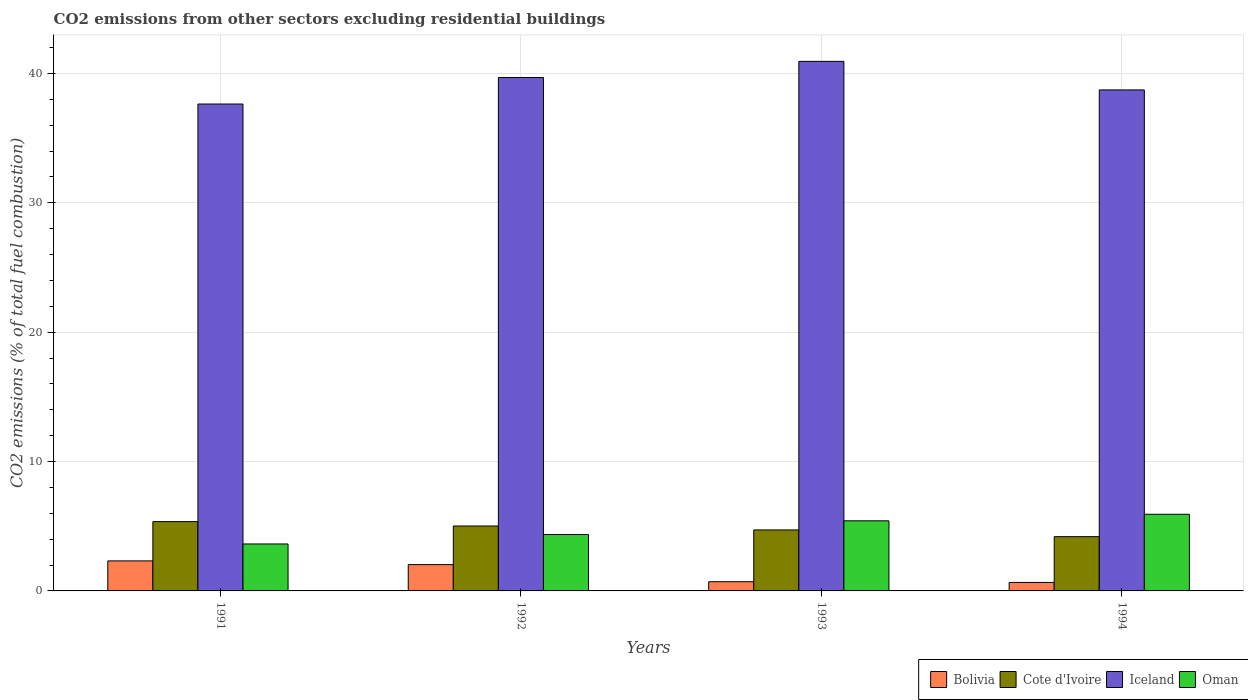How many groups of bars are there?
Offer a terse response. 4. How many bars are there on the 3rd tick from the left?
Offer a terse response. 4. What is the total CO2 emitted in Cote d'Ivoire in 1994?
Provide a short and direct response. 4.19. Across all years, what is the maximum total CO2 emitted in Cote d'Ivoire?
Your response must be concise. 5.36. Across all years, what is the minimum total CO2 emitted in Oman?
Keep it short and to the point. 3.63. In which year was the total CO2 emitted in Iceland maximum?
Your response must be concise. 1993. What is the total total CO2 emitted in Cote d'Ivoire in the graph?
Provide a short and direct response. 19.28. What is the difference between the total CO2 emitted in Bolivia in 1991 and that in 1992?
Offer a terse response. 0.29. What is the difference between the total CO2 emitted in Bolivia in 1992 and the total CO2 emitted in Oman in 1991?
Your response must be concise. -1.6. What is the average total CO2 emitted in Cote d'Ivoire per year?
Offer a terse response. 4.82. In the year 1991, what is the difference between the total CO2 emitted in Bolivia and total CO2 emitted in Oman?
Give a very brief answer. -1.31. In how many years, is the total CO2 emitted in Bolivia greater than 30?
Offer a terse response. 0. What is the ratio of the total CO2 emitted in Oman in 1991 to that in 1993?
Offer a very short reply. 0.67. Is the difference between the total CO2 emitted in Bolivia in 1992 and 1993 greater than the difference between the total CO2 emitted in Oman in 1992 and 1993?
Your answer should be compact. Yes. What is the difference between the highest and the second highest total CO2 emitted in Iceland?
Your answer should be compact. 1.25. What is the difference between the highest and the lowest total CO2 emitted in Iceland?
Offer a very short reply. 3.3. Is the sum of the total CO2 emitted in Oman in 1992 and 1994 greater than the maximum total CO2 emitted in Bolivia across all years?
Your response must be concise. Yes. Is it the case that in every year, the sum of the total CO2 emitted in Iceland and total CO2 emitted in Oman is greater than the sum of total CO2 emitted in Bolivia and total CO2 emitted in Cote d'Ivoire?
Offer a terse response. Yes. What does the 4th bar from the left in 1991 represents?
Ensure brevity in your answer.  Oman. Is it the case that in every year, the sum of the total CO2 emitted in Bolivia and total CO2 emitted in Oman is greater than the total CO2 emitted in Cote d'Ivoire?
Give a very brief answer. Yes. How many bars are there?
Give a very brief answer. 16. What is the difference between two consecutive major ticks on the Y-axis?
Ensure brevity in your answer.  10. Does the graph contain any zero values?
Provide a short and direct response. No. What is the title of the graph?
Offer a terse response. CO2 emissions from other sectors excluding residential buildings. What is the label or title of the X-axis?
Your answer should be compact. Years. What is the label or title of the Y-axis?
Your answer should be compact. CO2 emissions (% of total fuel combustion). What is the CO2 emissions (% of total fuel combustion) in Bolivia in 1991?
Your answer should be compact. 2.32. What is the CO2 emissions (% of total fuel combustion) in Cote d'Ivoire in 1991?
Offer a very short reply. 5.36. What is the CO2 emissions (% of total fuel combustion) in Iceland in 1991?
Offer a terse response. 37.63. What is the CO2 emissions (% of total fuel combustion) of Oman in 1991?
Your answer should be compact. 3.63. What is the CO2 emissions (% of total fuel combustion) of Bolivia in 1992?
Keep it short and to the point. 2.03. What is the CO2 emissions (% of total fuel combustion) in Cote d'Ivoire in 1992?
Ensure brevity in your answer.  5.02. What is the CO2 emissions (% of total fuel combustion) of Iceland in 1992?
Your answer should be very brief. 39.68. What is the CO2 emissions (% of total fuel combustion) of Oman in 1992?
Provide a succinct answer. 4.36. What is the CO2 emissions (% of total fuel combustion) in Bolivia in 1993?
Your answer should be compact. 0.71. What is the CO2 emissions (% of total fuel combustion) in Cote d'Ivoire in 1993?
Make the answer very short. 4.71. What is the CO2 emissions (% of total fuel combustion) of Iceland in 1993?
Provide a succinct answer. 40.93. What is the CO2 emissions (% of total fuel combustion) in Oman in 1993?
Give a very brief answer. 5.42. What is the CO2 emissions (% of total fuel combustion) in Bolivia in 1994?
Give a very brief answer. 0.66. What is the CO2 emissions (% of total fuel combustion) of Cote d'Ivoire in 1994?
Keep it short and to the point. 4.19. What is the CO2 emissions (% of total fuel combustion) of Iceland in 1994?
Offer a very short reply. 38.73. What is the CO2 emissions (% of total fuel combustion) in Oman in 1994?
Provide a succinct answer. 5.92. Across all years, what is the maximum CO2 emissions (% of total fuel combustion) of Bolivia?
Provide a short and direct response. 2.32. Across all years, what is the maximum CO2 emissions (% of total fuel combustion) of Cote d'Ivoire?
Your answer should be very brief. 5.36. Across all years, what is the maximum CO2 emissions (% of total fuel combustion) in Iceland?
Give a very brief answer. 40.93. Across all years, what is the maximum CO2 emissions (% of total fuel combustion) of Oman?
Your answer should be very brief. 5.92. Across all years, what is the minimum CO2 emissions (% of total fuel combustion) in Bolivia?
Give a very brief answer. 0.66. Across all years, what is the minimum CO2 emissions (% of total fuel combustion) of Cote d'Ivoire?
Ensure brevity in your answer.  4.19. Across all years, what is the minimum CO2 emissions (% of total fuel combustion) of Iceland?
Offer a very short reply. 37.63. Across all years, what is the minimum CO2 emissions (% of total fuel combustion) of Oman?
Offer a terse response. 3.63. What is the total CO2 emissions (% of total fuel combustion) of Bolivia in the graph?
Ensure brevity in your answer.  5.72. What is the total CO2 emissions (% of total fuel combustion) of Cote d'Ivoire in the graph?
Provide a succinct answer. 19.28. What is the total CO2 emissions (% of total fuel combustion) of Iceland in the graph?
Provide a succinct answer. 156.98. What is the total CO2 emissions (% of total fuel combustion) of Oman in the graph?
Your answer should be compact. 19.33. What is the difference between the CO2 emissions (% of total fuel combustion) of Bolivia in 1991 and that in 1992?
Offer a terse response. 0.29. What is the difference between the CO2 emissions (% of total fuel combustion) of Cote d'Ivoire in 1991 and that in 1992?
Make the answer very short. 0.34. What is the difference between the CO2 emissions (% of total fuel combustion) in Iceland in 1991 and that in 1992?
Your response must be concise. -2.05. What is the difference between the CO2 emissions (% of total fuel combustion) in Oman in 1991 and that in 1992?
Give a very brief answer. -0.73. What is the difference between the CO2 emissions (% of total fuel combustion) in Bolivia in 1991 and that in 1993?
Make the answer very short. 1.61. What is the difference between the CO2 emissions (% of total fuel combustion) in Cote d'Ivoire in 1991 and that in 1993?
Make the answer very short. 0.64. What is the difference between the CO2 emissions (% of total fuel combustion) in Iceland in 1991 and that in 1993?
Make the answer very short. -3.3. What is the difference between the CO2 emissions (% of total fuel combustion) of Oman in 1991 and that in 1993?
Provide a succinct answer. -1.79. What is the difference between the CO2 emissions (% of total fuel combustion) in Bolivia in 1991 and that in 1994?
Your answer should be compact. 1.67. What is the difference between the CO2 emissions (% of total fuel combustion) of Cote d'Ivoire in 1991 and that in 1994?
Your answer should be compact. 1.16. What is the difference between the CO2 emissions (% of total fuel combustion) in Iceland in 1991 and that in 1994?
Keep it short and to the point. -1.09. What is the difference between the CO2 emissions (% of total fuel combustion) of Oman in 1991 and that in 1994?
Give a very brief answer. -2.29. What is the difference between the CO2 emissions (% of total fuel combustion) in Bolivia in 1992 and that in 1993?
Provide a succinct answer. 1.32. What is the difference between the CO2 emissions (% of total fuel combustion) of Cote d'Ivoire in 1992 and that in 1993?
Provide a succinct answer. 0.3. What is the difference between the CO2 emissions (% of total fuel combustion) in Iceland in 1992 and that in 1993?
Provide a succinct answer. -1.25. What is the difference between the CO2 emissions (% of total fuel combustion) in Oman in 1992 and that in 1993?
Your answer should be compact. -1.06. What is the difference between the CO2 emissions (% of total fuel combustion) of Bolivia in 1992 and that in 1994?
Your answer should be very brief. 1.38. What is the difference between the CO2 emissions (% of total fuel combustion) of Cote d'Ivoire in 1992 and that in 1994?
Make the answer very short. 0.82. What is the difference between the CO2 emissions (% of total fuel combustion) in Oman in 1992 and that in 1994?
Make the answer very short. -1.57. What is the difference between the CO2 emissions (% of total fuel combustion) of Bolivia in 1993 and that in 1994?
Provide a succinct answer. 0.06. What is the difference between the CO2 emissions (% of total fuel combustion) of Cote d'Ivoire in 1993 and that in 1994?
Keep it short and to the point. 0.52. What is the difference between the CO2 emissions (% of total fuel combustion) of Iceland in 1993 and that in 1994?
Your response must be concise. 2.21. What is the difference between the CO2 emissions (% of total fuel combustion) of Oman in 1993 and that in 1994?
Provide a short and direct response. -0.51. What is the difference between the CO2 emissions (% of total fuel combustion) of Bolivia in 1991 and the CO2 emissions (% of total fuel combustion) of Cote d'Ivoire in 1992?
Keep it short and to the point. -2.7. What is the difference between the CO2 emissions (% of total fuel combustion) in Bolivia in 1991 and the CO2 emissions (% of total fuel combustion) in Iceland in 1992?
Offer a very short reply. -37.36. What is the difference between the CO2 emissions (% of total fuel combustion) in Bolivia in 1991 and the CO2 emissions (% of total fuel combustion) in Oman in 1992?
Make the answer very short. -2.04. What is the difference between the CO2 emissions (% of total fuel combustion) of Cote d'Ivoire in 1991 and the CO2 emissions (% of total fuel combustion) of Iceland in 1992?
Keep it short and to the point. -34.33. What is the difference between the CO2 emissions (% of total fuel combustion) in Iceland in 1991 and the CO2 emissions (% of total fuel combustion) in Oman in 1992?
Offer a very short reply. 33.28. What is the difference between the CO2 emissions (% of total fuel combustion) in Bolivia in 1991 and the CO2 emissions (% of total fuel combustion) in Cote d'Ivoire in 1993?
Keep it short and to the point. -2.39. What is the difference between the CO2 emissions (% of total fuel combustion) of Bolivia in 1991 and the CO2 emissions (% of total fuel combustion) of Iceland in 1993?
Your answer should be very brief. -38.61. What is the difference between the CO2 emissions (% of total fuel combustion) of Bolivia in 1991 and the CO2 emissions (% of total fuel combustion) of Oman in 1993?
Ensure brevity in your answer.  -3.1. What is the difference between the CO2 emissions (% of total fuel combustion) of Cote d'Ivoire in 1991 and the CO2 emissions (% of total fuel combustion) of Iceland in 1993?
Give a very brief answer. -35.58. What is the difference between the CO2 emissions (% of total fuel combustion) of Cote d'Ivoire in 1991 and the CO2 emissions (% of total fuel combustion) of Oman in 1993?
Provide a short and direct response. -0.06. What is the difference between the CO2 emissions (% of total fuel combustion) in Iceland in 1991 and the CO2 emissions (% of total fuel combustion) in Oman in 1993?
Make the answer very short. 32.22. What is the difference between the CO2 emissions (% of total fuel combustion) in Bolivia in 1991 and the CO2 emissions (% of total fuel combustion) in Cote d'Ivoire in 1994?
Provide a succinct answer. -1.87. What is the difference between the CO2 emissions (% of total fuel combustion) in Bolivia in 1991 and the CO2 emissions (% of total fuel combustion) in Iceland in 1994?
Your answer should be very brief. -36.4. What is the difference between the CO2 emissions (% of total fuel combustion) in Bolivia in 1991 and the CO2 emissions (% of total fuel combustion) in Oman in 1994?
Provide a succinct answer. -3.6. What is the difference between the CO2 emissions (% of total fuel combustion) in Cote d'Ivoire in 1991 and the CO2 emissions (% of total fuel combustion) in Iceland in 1994?
Give a very brief answer. -33.37. What is the difference between the CO2 emissions (% of total fuel combustion) in Cote d'Ivoire in 1991 and the CO2 emissions (% of total fuel combustion) in Oman in 1994?
Ensure brevity in your answer.  -0.57. What is the difference between the CO2 emissions (% of total fuel combustion) in Iceland in 1991 and the CO2 emissions (% of total fuel combustion) in Oman in 1994?
Make the answer very short. 31.71. What is the difference between the CO2 emissions (% of total fuel combustion) in Bolivia in 1992 and the CO2 emissions (% of total fuel combustion) in Cote d'Ivoire in 1993?
Your answer should be very brief. -2.68. What is the difference between the CO2 emissions (% of total fuel combustion) of Bolivia in 1992 and the CO2 emissions (% of total fuel combustion) of Iceland in 1993?
Keep it short and to the point. -38.9. What is the difference between the CO2 emissions (% of total fuel combustion) of Bolivia in 1992 and the CO2 emissions (% of total fuel combustion) of Oman in 1993?
Your answer should be compact. -3.39. What is the difference between the CO2 emissions (% of total fuel combustion) in Cote d'Ivoire in 1992 and the CO2 emissions (% of total fuel combustion) in Iceland in 1993?
Provide a short and direct response. -35.91. What is the difference between the CO2 emissions (% of total fuel combustion) in Cote d'Ivoire in 1992 and the CO2 emissions (% of total fuel combustion) in Oman in 1993?
Provide a succinct answer. -0.4. What is the difference between the CO2 emissions (% of total fuel combustion) in Iceland in 1992 and the CO2 emissions (% of total fuel combustion) in Oman in 1993?
Give a very brief answer. 34.26. What is the difference between the CO2 emissions (% of total fuel combustion) in Bolivia in 1992 and the CO2 emissions (% of total fuel combustion) in Cote d'Ivoire in 1994?
Keep it short and to the point. -2.16. What is the difference between the CO2 emissions (% of total fuel combustion) of Bolivia in 1992 and the CO2 emissions (% of total fuel combustion) of Iceland in 1994?
Provide a succinct answer. -36.69. What is the difference between the CO2 emissions (% of total fuel combustion) of Bolivia in 1992 and the CO2 emissions (% of total fuel combustion) of Oman in 1994?
Keep it short and to the point. -3.89. What is the difference between the CO2 emissions (% of total fuel combustion) in Cote d'Ivoire in 1992 and the CO2 emissions (% of total fuel combustion) in Iceland in 1994?
Your response must be concise. -33.71. What is the difference between the CO2 emissions (% of total fuel combustion) of Cote d'Ivoire in 1992 and the CO2 emissions (% of total fuel combustion) of Oman in 1994?
Make the answer very short. -0.91. What is the difference between the CO2 emissions (% of total fuel combustion) in Iceland in 1992 and the CO2 emissions (% of total fuel combustion) in Oman in 1994?
Ensure brevity in your answer.  33.76. What is the difference between the CO2 emissions (% of total fuel combustion) in Bolivia in 1993 and the CO2 emissions (% of total fuel combustion) in Cote d'Ivoire in 1994?
Ensure brevity in your answer.  -3.48. What is the difference between the CO2 emissions (% of total fuel combustion) in Bolivia in 1993 and the CO2 emissions (% of total fuel combustion) in Iceland in 1994?
Ensure brevity in your answer.  -38.01. What is the difference between the CO2 emissions (% of total fuel combustion) in Bolivia in 1993 and the CO2 emissions (% of total fuel combustion) in Oman in 1994?
Make the answer very short. -5.21. What is the difference between the CO2 emissions (% of total fuel combustion) in Cote d'Ivoire in 1993 and the CO2 emissions (% of total fuel combustion) in Iceland in 1994?
Ensure brevity in your answer.  -34.01. What is the difference between the CO2 emissions (% of total fuel combustion) of Cote d'Ivoire in 1993 and the CO2 emissions (% of total fuel combustion) of Oman in 1994?
Provide a short and direct response. -1.21. What is the difference between the CO2 emissions (% of total fuel combustion) of Iceland in 1993 and the CO2 emissions (% of total fuel combustion) of Oman in 1994?
Ensure brevity in your answer.  35.01. What is the average CO2 emissions (% of total fuel combustion) of Bolivia per year?
Offer a very short reply. 1.43. What is the average CO2 emissions (% of total fuel combustion) of Cote d'Ivoire per year?
Offer a terse response. 4.82. What is the average CO2 emissions (% of total fuel combustion) in Iceland per year?
Your response must be concise. 39.24. What is the average CO2 emissions (% of total fuel combustion) of Oman per year?
Offer a terse response. 4.83. In the year 1991, what is the difference between the CO2 emissions (% of total fuel combustion) in Bolivia and CO2 emissions (% of total fuel combustion) in Cote d'Ivoire?
Ensure brevity in your answer.  -3.04. In the year 1991, what is the difference between the CO2 emissions (% of total fuel combustion) in Bolivia and CO2 emissions (% of total fuel combustion) in Iceland?
Provide a short and direct response. -35.31. In the year 1991, what is the difference between the CO2 emissions (% of total fuel combustion) of Bolivia and CO2 emissions (% of total fuel combustion) of Oman?
Your answer should be compact. -1.31. In the year 1991, what is the difference between the CO2 emissions (% of total fuel combustion) of Cote d'Ivoire and CO2 emissions (% of total fuel combustion) of Iceland?
Your answer should be very brief. -32.28. In the year 1991, what is the difference between the CO2 emissions (% of total fuel combustion) in Cote d'Ivoire and CO2 emissions (% of total fuel combustion) in Oman?
Your answer should be compact. 1.73. In the year 1991, what is the difference between the CO2 emissions (% of total fuel combustion) in Iceland and CO2 emissions (% of total fuel combustion) in Oman?
Make the answer very short. 34. In the year 1992, what is the difference between the CO2 emissions (% of total fuel combustion) in Bolivia and CO2 emissions (% of total fuel combustion) in Cote d'Ivoire?
Your answer should be very brief. -2.98. In the year 1992, what is the difference between the CO2 emissions (% of total fuel combustion) in Bolivia and CO2 emissions (% of total fuel combustion) in Iceland?
Provide a short and direct response. -37.65. In the year 1992, what is the difference between the CO2 emissions (% of total fuel combustion) of Bolivia and CO2 emissions (% of total fuel combustion) of Oman?
Provide a succinct answer. -2.32. In the year 1992, what is the difference between the CO2 emissions (% of total fuel combustion) of Cote d'Ivoire and CO2 emissions (% of total fuel combustion) of Iceland?
Make the answer very short. -34.66. In the year 1992, what is the difference between the CO2 emissions (% of total fuel combustion) of Cote d'Ivoire and CO2 emissions (% of total fuel combustion) of Oman?
Your answer should be very brief. 0.66. In the year 1992, what is the difference between the CO2 emissions (% of total fuel combustion) in Iceland and CO2 emissions (% of total fuel combustion) in Oman?
Your answer should be very brief. 35.32. In the year 1993, what is the difference between the CO2 emissions (% of total fuel combustion) of Bolivia and CO2 emissions (% of total fuel combustion) of Cote d'Ivoire?
Your response must be concise. -4. In the year 1993, what is the difference between the CO2 emissions (% of total fuel combustion) of Bolivia and CO2 emissions (% of total fuel combustion) of Iceland?
Provide a succinct answer. -40.22. In the year 1993, what is the difference between the CO2 emissions (% of total fuel combustion) in Bolivia and CO2 emissions (% of total fuel combustion) in Oman?
Ensure brevity in your answer.  -4.71. In the year 1993, what is the difference between the CO2 emissions (% of total fuel combustion) in Cote d'Ivoire and CO2 emissions (% of total fuel combustion) in Iceland?
Offer a terse response. -36.22. In the year 1993, what is the difference between the CO2 emissions (% of total fuel combustion) of Cote d'Ivoire and CO2 emissions (% of total fuel combustion) of Oman?
Make the answer very short. -0.7. In the year 1993, what is the difference between the CO2 emissions (% of total fuel combustion) of Iceland and CO2 emissions (% of total fuel combustion) of Oman?
Keep it short and to the point. 35.51. In the year 1994, what is the difference between the CO2 emissions (% of total fuel combustion) of Bolivia and CO2 emissions (% of total fuel combustion) of Cote d'Ivoire?
Provide a succinct answer. -3.54. In the year 1994, what is the difference between the CO2 emissions (% of total fuel combustion) of Bolivia and CO2 emissions (% of total fuel combustion) of Iceland?
Keep it short and to the point. -38.07. In the year 1994, what is the difference between the CO2 emissions (% of total fuel combustion) in Bolivia and CO2 emissions (% of total fuel combustion) in Oman?
Offer a terse response. -5.27. In the year 1994, what is the difference between the CO2 emissions (% of total fuel combustion) in Cote d'Ivoire and CO2 emissions (% of total fuel combustion) in Iceland?
Make the answer very short. -34.53. In the year 1994, what is the difference between the CO2 emissions (% of total fuel combustion) in Cote d'Ivoire and CO2 emissions (% of total fuel combustion) in Oman?
Keep it short and to the point. -1.73. In the year 1994, what is the difference between the CO2 emissions (% of total fuel combustion) of Iceland and CO2 emissions (% of total fuel combustion) of Oman?
Make the answer very short. 32.8. What is the ratio of the CO2 emissions (% of total fuel combustion) of Bolivia in 1991 to that in 1992?
Ensure brevity in your answer.  1.14. What is the ratio of the CO2 emissions (% of total fuel combustion) in Cote d'Ivoire in 1991 to that in 1992?
Provide a short and direct response. 1.07. What is the ratio of the CO2 emissions (% of total fuel combustion) of Iceland in 1991 to that in 1992?
Give a very brief answer. 0.95. What is the ratio of the CO2 emissions (% of total fuel combustion) of Oman in 1991 to that in 1992?
Your answer should be compact. 0.83. What is the ratio of the CO2 emissions (% of total fuel combustion) of Bolivia in 1991 to that in 1993?
Your answer should be compact. 3.26. What is the ratio of the CO2 emissions (% of total fuel combustion) in Cote d'Ivoire in 1991 to that in 1993?
Offer a terse response. 1.14. What is the ratio of the CO2 emissions (% of total fuel combustion) of Iceland in 1991 to that in 1993?
Your answer should be very brief. 0.92. What is the ratio of the CO2 emissions (% of total fuel combustion) of Oman in 1991 to that in 1993?
Your response must be concise. 0.67. What is the ratio of the CO2 emissions (% of total fuel combustion) of Bolivia in 1991 to that in 1994?
Give a very brief answer. 3.54. What is the ratio of the CO2 emissions (% of total fuel combustion) in Cote d'Ivoire in 1991 to that in 1994?
Offer a terse response. 1.28. What is the ratio of the CO2 emissions (% of total fuel combustion) of Iceland in 1991 to that in 1994?
Offer a very short reply. 0.97. What is the ratio of the CO2 emissions (% of total fuel combustion) in Oman in 1991 to that in 1994?
Offer a very short reply. 0.61. What is the ratio of the CO2 emissions (% of total fuel combustion) in Bolivia in 1992 to that in 1993?
Your response must be concise. 2.86. What is the ratio of the CO2 emissions (% of total fuel combustion) in Cote d'Ivoire in 1992 to that in 1993?
Keep it short and to the point. 1.06. What is the ratio of the CO2 emissions (% of total fuel combustion) of Iceland in 1992 to that in 1993?
Your response must be concise. 0.97. What is the ratio of the CO2 emissions (% of total fuel combustion) of Oman in 1992 to that in 1993?
Provide a short and direct response. 0.8. What is the ratio of the CO2 emissions (% of total fuel combustion) in Bolivia in 1992 to that in 1994?
Your answer should be compact. 3.1. What is the ratio of the CO2 emissions (% of total fuel combustion) of Cote d'Ivoire in 1992 to that in 1994?
Offer a terse response. 1.2. What is the ratio of the CO2 emissions (% of total fuel combustion) of Iceland in 1992 to that in 1994?
Give a very brief answer. 1.02. What is the ratio of the CO2 emissions (% of total fuel combustion) in Oman in 1992 to that in 1994?
Your answer should be compact. 0.74. What is the ratio of the CO2 emissions (% of total fuel combustion) of Bolivia in 1993 to that in 1994?
Ensure brevity in your answer.  1.09. What is the ratio of the CO2 emissions (% of total fuel combustion) of Cote d'Ivoire in 1993 to that in 1994?
Keep it short and to the point. 1.12. What is the ratio of the CO2 emissions (% of total fuel combustion) of Iceland in 1993 to that in 1994?
Give a very brief answer. 1.06. What is the ratio of the CO2 emissions (% of total fuel combustion) of Oman in 1993 to that in 1994?
Ensure brevity in your answer.  0.91. What is the difference between the highest and the second highest CO2 emissions (% of total fuel combustion) in Bolivia?
Ensure brevity in your answer.  0.29. What is the difference between the highest and the second highest CO2 emissions (% of total fuel combustion) in Cote d'Ivoire?
Offer a very short reply. 0.34. What is the difference between the highest and the second highest CO2 emissions (% of total fuel combustion) of Iceland?
Keep it short and to the point. 1.25. What is the difference between the highest and the second highest CO2 emissions (% of total fuel combustion) of Oman?
Provide a succinct answer. 0.51. What is the difference between the highest and the lowest CO2 emissions (% of total fuel combustion) of Bolivia?
Give a very brief answer. 1.67. What is the difference between the highest and the lowest CO2 emissions (% of total fuel combustion) in Cote d'Ivoire?
Offer a very short reply. 1.16. What is the difference between the highest and the lowest CO2 emissions (% of total fuel combustion) of Iceland?
Provide a short and direct response. 3.3. What is the difference between the highest and the lowest CO2 emissions (% of total fuel combustion) in Oman?
Provide a succinct answer. 2.29. 